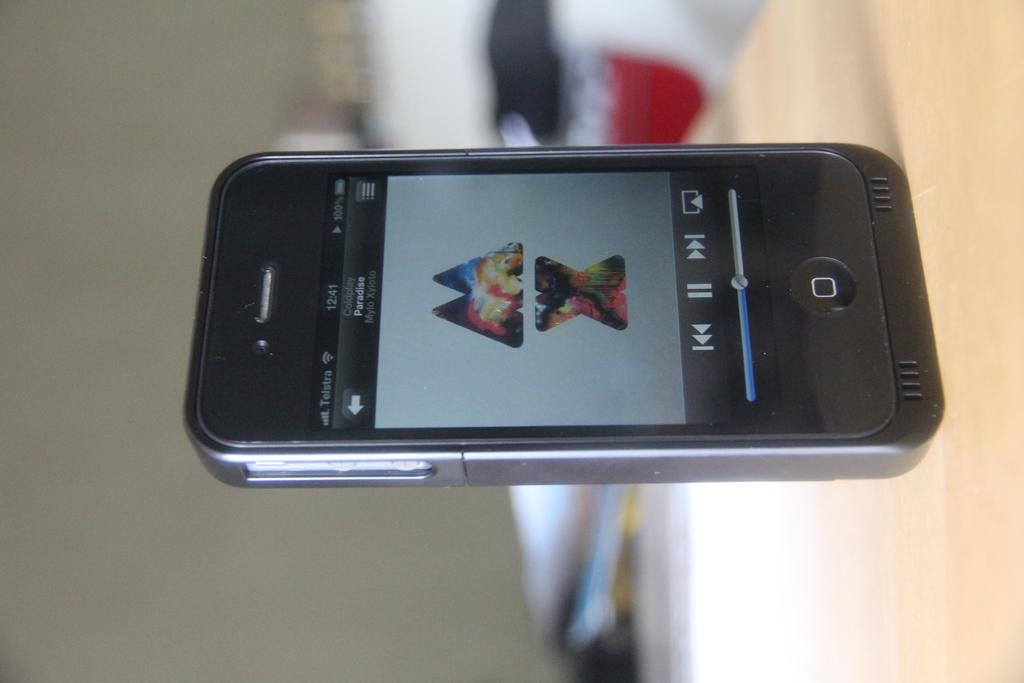Provide a one-sentence caption for the provided image. A phone displaying the letters M and X with pictures inside is sitting sideways. 